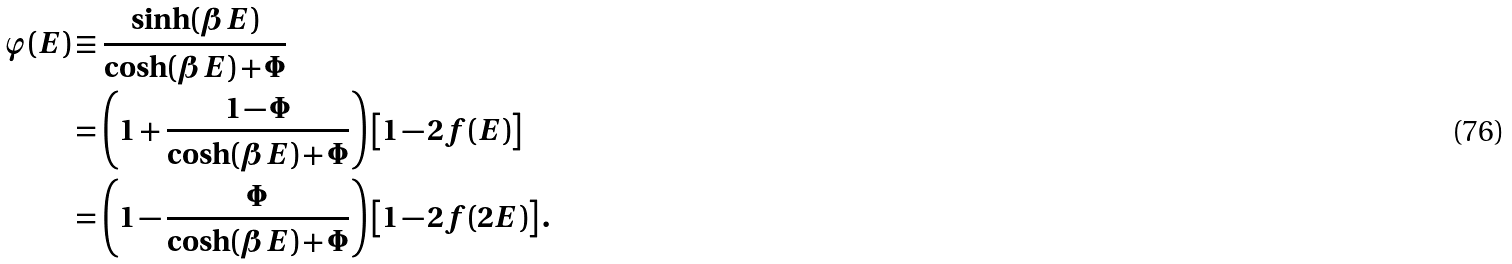<formula> <loc_0><loc_0><loc_500><loc_500>\varphi ( E ) & \equiv \frac { \sinh ( \beta E ) } { \cosh ( \beta E ) + \Phi } \\ & = \left ( 1 + \frac { 1 - \Phi } { \cosh ( \beta E ) + \Phi } \right ) \left [ 1 - 2 f ( E ) \right ] \\ & = \left ( 1 - \frac { \Phi } { \cosh ( \beta E ) + \Phi } \right ) \left [ 1 - 2 f ( 2 E ) \right ] .</formula> 